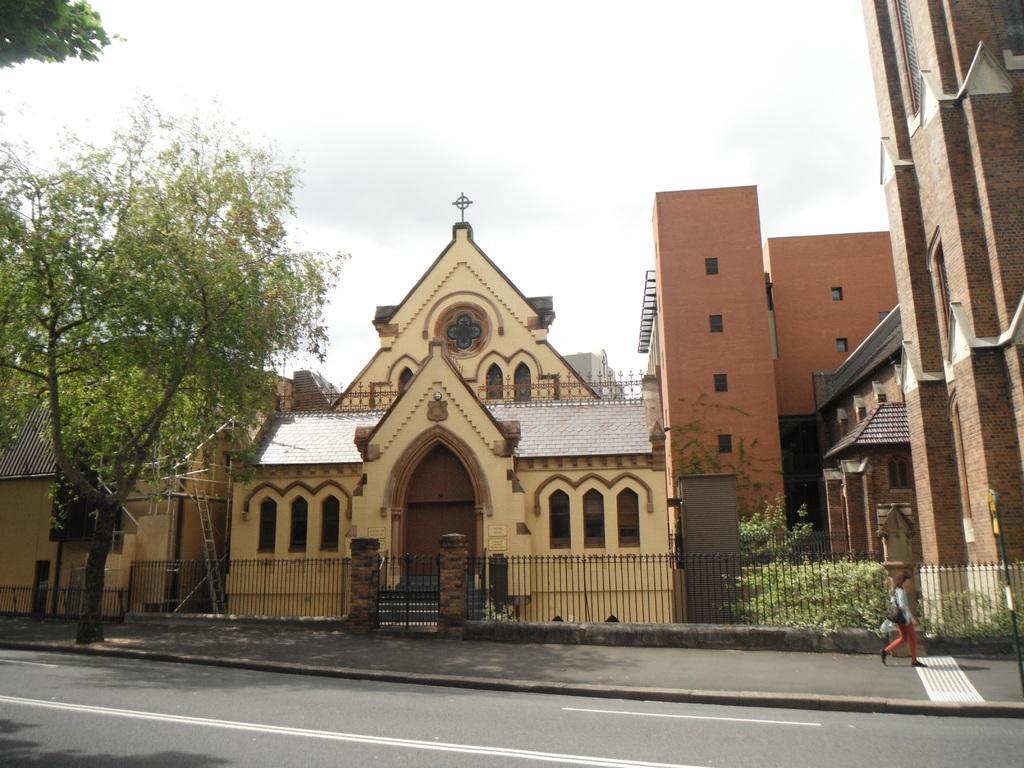Can you describe this image briefly? This image consists of many buildings along with a tree. At the bottom, there is a road. To the right, there is a woman walking. At the top, there is a sky. 